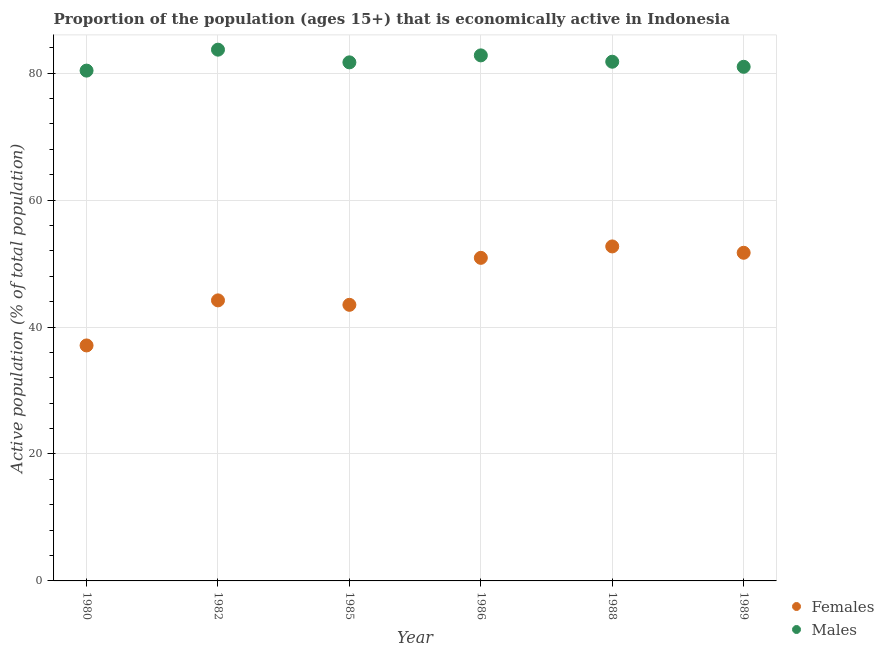How many different coloured dotlines are there?
Give a very brief answer. 2. Is the number of dotlines equal to the number of legend labels?
Provide a succinct answer. Yes. What is the percentage of economically active female population in 1986?
Provide a succinct answer. 50.9. Across all years, what is the maximum percentage of economically active male population?
Provide a succinct answer. 83.7. Across all years, what is the minimum percentage of economically active female population?
Offer a very short reply. 37.1. In which year was the percentage of economically active female population maximum?
Offer a very short reply. 1988. In which year was the percentage of economically active male population minimum?
Your response must be concise. 1980. What is the total percentage of economically active male population in the graph?
Provide a succinct answer. 491.4. What is the difference between the percentage of economically active male population in 1982 and that in 1988?
Offer a terse response. 1.9. What is the difference between the percentage of economically active female population in 1989 and the percentage of economically active male population in 1988?
Offer a terse response. -30.1. What is the average percentage of economically active male population per year?
Give a very brief answer. 81.9. In the year 1980, what is the difference between the percentage of economically active female population and percentage of economically active male population?
Your answer should be compact. -43.3. In how many years, is the percentage of economically active female population greater than 36 %?
Ensure brevity in your answer.  6. What is the ratio of the percentage of economically active female population in 1986 to that in 1988?
Your answer should be very brief. 0.97. Is the difference between the percentage of economically active female population in 1980 and 1988 greater than the difference between the percentage of economically active male population in 1980 and 1988?
Offer a very short reply. No. What is the difference between the highest and the second highest percentage of economically active male population?
Provide a succinct answer. 0.9. What is the difference between the highest and the lowest percentage of economically active female population?
Your response must be concise. 15.6. Is the percentage of economically active female population strictly greater than the percentage of economically active male population over the years?
Give a very brief answer. No. Is the percentage of economically active male population strictly less than the percentage of economically active female population over the years?
Your response must be concise. No. How many dotlines are there?
Your answer should be compact. 2. What is the difference between two consecutive major ticks on the Y-axis?
Provide a succinct answer. 20. Does the graph contain any zero values?
Ensure brevity in your answer.  No. Does the graph contain grids?
Offer a terse response. Yes. Where does the legend appear in the graph?
Your answer should be very brief. Bottom right. How are the legend labels stacked?
Provide a short and direct response. Vertical. What is the title of the graph?
Ensure brevity in your answer.  Proportion of the population (ages 15+) that is economically active in Indonesia. Does "ODA received" appear as one of the legend labels in the graph?
Your answer should be very brief. No. What is the label or title of the Y-axis?
Offer a terse response. Active population (% of total population). What is the Active population (% of total population) in Females in 1980?
Your answer should be very brief. 37.1. What is the Active population (% of total population) of Males in 1980?
Provide a short and direct response. 80.4. What is the Active population (% of total population) in Females in 1982?
Offer a very short reply. 44.2. What is the Active population (% of total population) of Males in 1982?
Offer a terse response. 83.7. What is the Active population (% of total population) of Females in 1985?
Offer a very short reply. 43.5. What is the Active population (% of total population) in Males in 1985?
Provide a short and direct response. 81.7. What is the Active population (% of total population) of Females in 1986?
Ensure brevity in your answer.  50.9. What is the Active population (% of total population) of Males in 1986?
Give a very brief answer. 82.8. What is the Active population (% of total population) of Females in 1988?
Your response must be concise. 52.7. What is the Active population (% of total population) of Males in 1988?
Make the answer very short. 81.8. What is the Active population (% of total population) in Females in 1989?
Provide a succinct answer. 51.7. What is the Active population (% of total population) in Males in 1989?
Offer a very short reply. 81. Across all years, what is the maximum Active population (% of total population) of Females?
Ensure brevity in your answer.  52.7. Across all years, what is the maximum Active population (% of total population) in Males?
Offer a terse response. 83.7. Across all years, what is the minimum Active population (% of total population) of Females?
Make the answer very short. 37.1. Across all years, what is the minimum Active population (% of total population) of Males?
Give a very brief answer. 80.4. What is the total Active population (% of total population) of Females in the graph?
Offer a terse response. 280.1. What is the total Active population (% of total population) in Males in the graph?
Your answer should be compact. 491.4. What is the difference between the Active population (% of total population) in Females in 1980 and that in 1982?
Offer a terse response. -7.1. What is the difference between the Active population (% of total population) in Males in 1980 and that in 1982?
Make the answer very short. -3.3. What is the difference between the Active population (% of total population) of Males in 1980 and that in 1985?
Make the answer very short. -1.3. What is the difference between the Active population (% of total population) of Females in 1980 and that in 1986?
Your answer should be very brief. -13.8. What is the difference between the Active population (% of total population) of Males in 1980 and that in 1986?
Your answer should be very brief. -2.4. What is the difference between the Active population (% of total population) in Females in 1980 and that in 1988?
Offer a very short reply. -15.6. What is the difference between the Active population (% of total population) in Females in 1980 and that in 1989?
Provide a succinct answer. -14.6. What is the difference between the Active population (% of total population) of Males in 1980 and that in 1989?
Provide a succinct answer. -0.6. What is the difference between the Active population (% of total population) in Females in 1982 and that in 1985?
Give a very brief answer. 0.7. What is the difference between the Active population (% of total population) of Females in 1982 and that in 1989?
Keep it short and to the point. -7.5. What is the difference between the Active population (% of total population) of Males in 1982 and that in 1989?
Offer a terse response. 2.7. What is the difference between the Active population (% of total population) of Females in 1985 and that in 1986?
Keep it short and to the point. -7.4. What is the difference between the Active population (% of total population) of Males in 1985 and that in 1986?
Offer a terse response. -1.1. What is the difference between the Active population (% of total population) of Males in 1985 and that in 1988?
Your answer should be very brief. -0.1. What is the difference between the Active population (% of total population) in Females in 1986 and that in 1988?
Provide a short and direct response. -1.8. What is the difference between the Active population (% of total population) in Males in 1988 and that in 1989?
Ensure brevity in your answer.  0.8. What is the difference between the Active population (% of total population) in Females in 1980 and the Active population (% of total population) in Males in 1982?
Ensure brevity in your answer.  -46.6. What is the difference between the Active population (% of total population) in Females in 1980 and the Active population (% of total population) in Males in 1985?
Offer a very short reply. -44.6. What is the difference between the Active population (% of total population) of Females in 1980 and the Active population (% of total population) of Males in 1986?
Give a very brief answer. -45.7. What is the difference between the Active population (% of total population) in Females in 1980 and the Active population (% of total population) in Males in 1988?
Offer a terse response. -44.7. What is the difference between the Active population (% of total population) of Females in 1980 and the Active population (% of total population) of Males in 1989?
Your answer should be very brief. -43.9. What is the difference between the Active population (% of total population) of Females in 1982 and the Active population (% of total population) of Males in 1985?
Offer a terse response. -37.5. What is the difference between the Active population (% of total population) in Females in 1982 and the Active population (% of total population) in Males in 1986?
Provide a short and direct response. -38.6. What is the difference between the Active population (% of total population) in Females in 1982 and the Active population (% of total population) in Males in 1988?
Offer a very short reply. -37.6. What is the difference between the Active population (% of total population) in Females in 1982 and the Active population (% of total population) in Males in 1989?
Give a very brief answer. -36.8. What is the difference between the Active population (% of total population) of Females in 1985 and the Active population (% of total population) of Males in 1986?
Ensure brevity in your answer.  -39.3. What is the difference between the Active population (% of total population) in Females in 1985 and the Active population (% of total population) in Males in 1988?
Your answer should be compact. -38.3. What is the difference between the Active population (% of total population) in Females in 1985 and the Active population (% of total population) in Males in 1989?
Your answer should be very brief. -37.5. What is the difference between the Active population (% of total population) in Females in 1986 and the Active population (% of total population) in Males in 1988?
Keep it short and to the point. -30.9. What is the difference between the Active population (% of total population) of Females in 1986 and the Active population (% of total population) of Males in 1989?
Keep it short and to the point. -30.1. What is the difference between the Active population (% of total population) of Females in 1988 and the Active population (% of total population) of Males in 1989?
Keep it short and to the point. -28.3. What is the average Active population (% of total population) in Females per year?
Provide a short and direct response. 46.68. What is the average Active population (% of total population) of Males per year?
Your answer should be compact. 81.9. In the year 1980, what is the difference between the Active population (% of total population) in Females and Active population (% of total population) in Males?
Give a very brief answer. -43.3. In the year 1982, what is the difference between the Active population (% of total population) of Females and Active population (% of total population) of Males?
Your response must be concise. -39.5. In the year 1985, what is the difference between the Active population (% of total population) of Females and Active population (% of total population) of Males?
Ensure brevity in your answer.  -38.2. In the year 1986, what is the difference between the Active population (% of total population) in Females and Active population (% of total population) in Males?
Your answer should be compact. -31.9. In the year 1988, what is the difference between the Active population (% of total population) in Females and Active population (% of total population) in Males?
Your answer should be compact. -29.1. In the year 1989, what is the difference between the Active population (% of total population) in Females and Active population (% of total population) in Males?
Offer a terse response. -29.3. What is the ratio of the Active population (% of total population) in Females in 1980 to that in 1982?
Your response must be concise. 0.84. What is the ratio of the Active population (% of total population) in Males in 1980 to that in 1982?
Provide a succinct answer. 0.96. What is the ratio of the Active population (% of total population) in Females in 1980 to that in 1985?
Your answer should be very brief. 0.85. What is the ratio of the Active population (% of total population) of Males in 1980 to that in 1985?
Provide a succinct answer. 0.98. What is the ratio of the Active population (% of total population) of Females in 1980 to that in 1986?
Provide a short and direct response. 0.73. What is the ratio of the Active population (% of total population) of Males in 1980 to that in 1986?
Your response must be concise. 0.97. What is the ratio of the Active population (% of total population) of Females in 1980 to that in 1988?
Offer a terse response. 0.7. What is the ratio of the Active population (% of total population) of Males in 1980 to that in 1988?
Make the answer very short. 0.98. What is the ratio of the Active population (% of total population) of Females in 1980 to that in 1989?
Keep it short and to the point. 0.72. What is the ratio of the Active population (% of total population) of Females in 1982 to that in 1985?
Keep it short and to the point. 1.02. What is the ratio of the Active population (% of total population) in Males in 1982 to that in 1985?
Your response must be concise. 1.02. What is the ratio of the Active population (% of total population) of Females in 1982 to that in 1986?
Your response must be concise. 0.87. What is the ratio of the Active population (% of total population) in Males in 1982 to that in 1986?
Provide a succinct answer. 1.01. What is the ratio of the Active population (% of total population) in Females in 1982 to that in 1988?
Provide a short and direct response. 0.84. What is the ratio of the Active population (% of total population) in Males in 1982 to that in 1988?
Ensure brevity in your answer.  1.02. What is the ratio of the Active population (% of total population) in Females in 1982 to that in 1989?
Your answer should be compact. 0.85. What is the ratio of the Active population (% of total population) in Males in 1982 to that in 1989?
Offer a terse response. 1.03. What is the ratio of the Active population (% of total population) in Females in 1985 to that in 1986?
Offer a terse response. 0.85. What is the ratio of the Active population (% of total population) of Males in 1985 to that in 1986?
Keep it short and to the point. 0.99. What is the ratio of the Active population (% of total population) of Females in 1985 to that in 1988?
Offer a very short reply. 0.83. What is the ratio of the Active population (% of total population) in Females in 1985 to that in 1989?
Make the answer very short. 0.84. What is the ratio of the Active population (% of total population) of Males in 1985 to that in 1989?
Make the answer very short. 1.01. What is the ratio of the Active population (% of total population) of Females in 1986 to that in 1988?
Your response must be concise. 0.97. What is the ratio of the Active population (% of total population) in Males in 1986 to that in 1988?
Offer a very short reply. 1.01. What is the ratio of the Active population (% of total population) in Females in 1986 to that in 1989?
Offer a terse response. 0.98. What is the ratio of the Active population (% of total population) of Males in 1986 to that in 1989?
Keep it short and to the point. 1.02. What is the ratio of the Active population (% of total population) in Females in 1988 to that in 1989?
Make the answer very short. 1.02. What is the ratio of the Active population (% of total population) of Males in 1988 to that in 1989?
Provide a short and direct response. 1.01. What is the difference between the highest and the second highest Active population (% of total population) in Males?
Give a very brief answer. 0.9. 